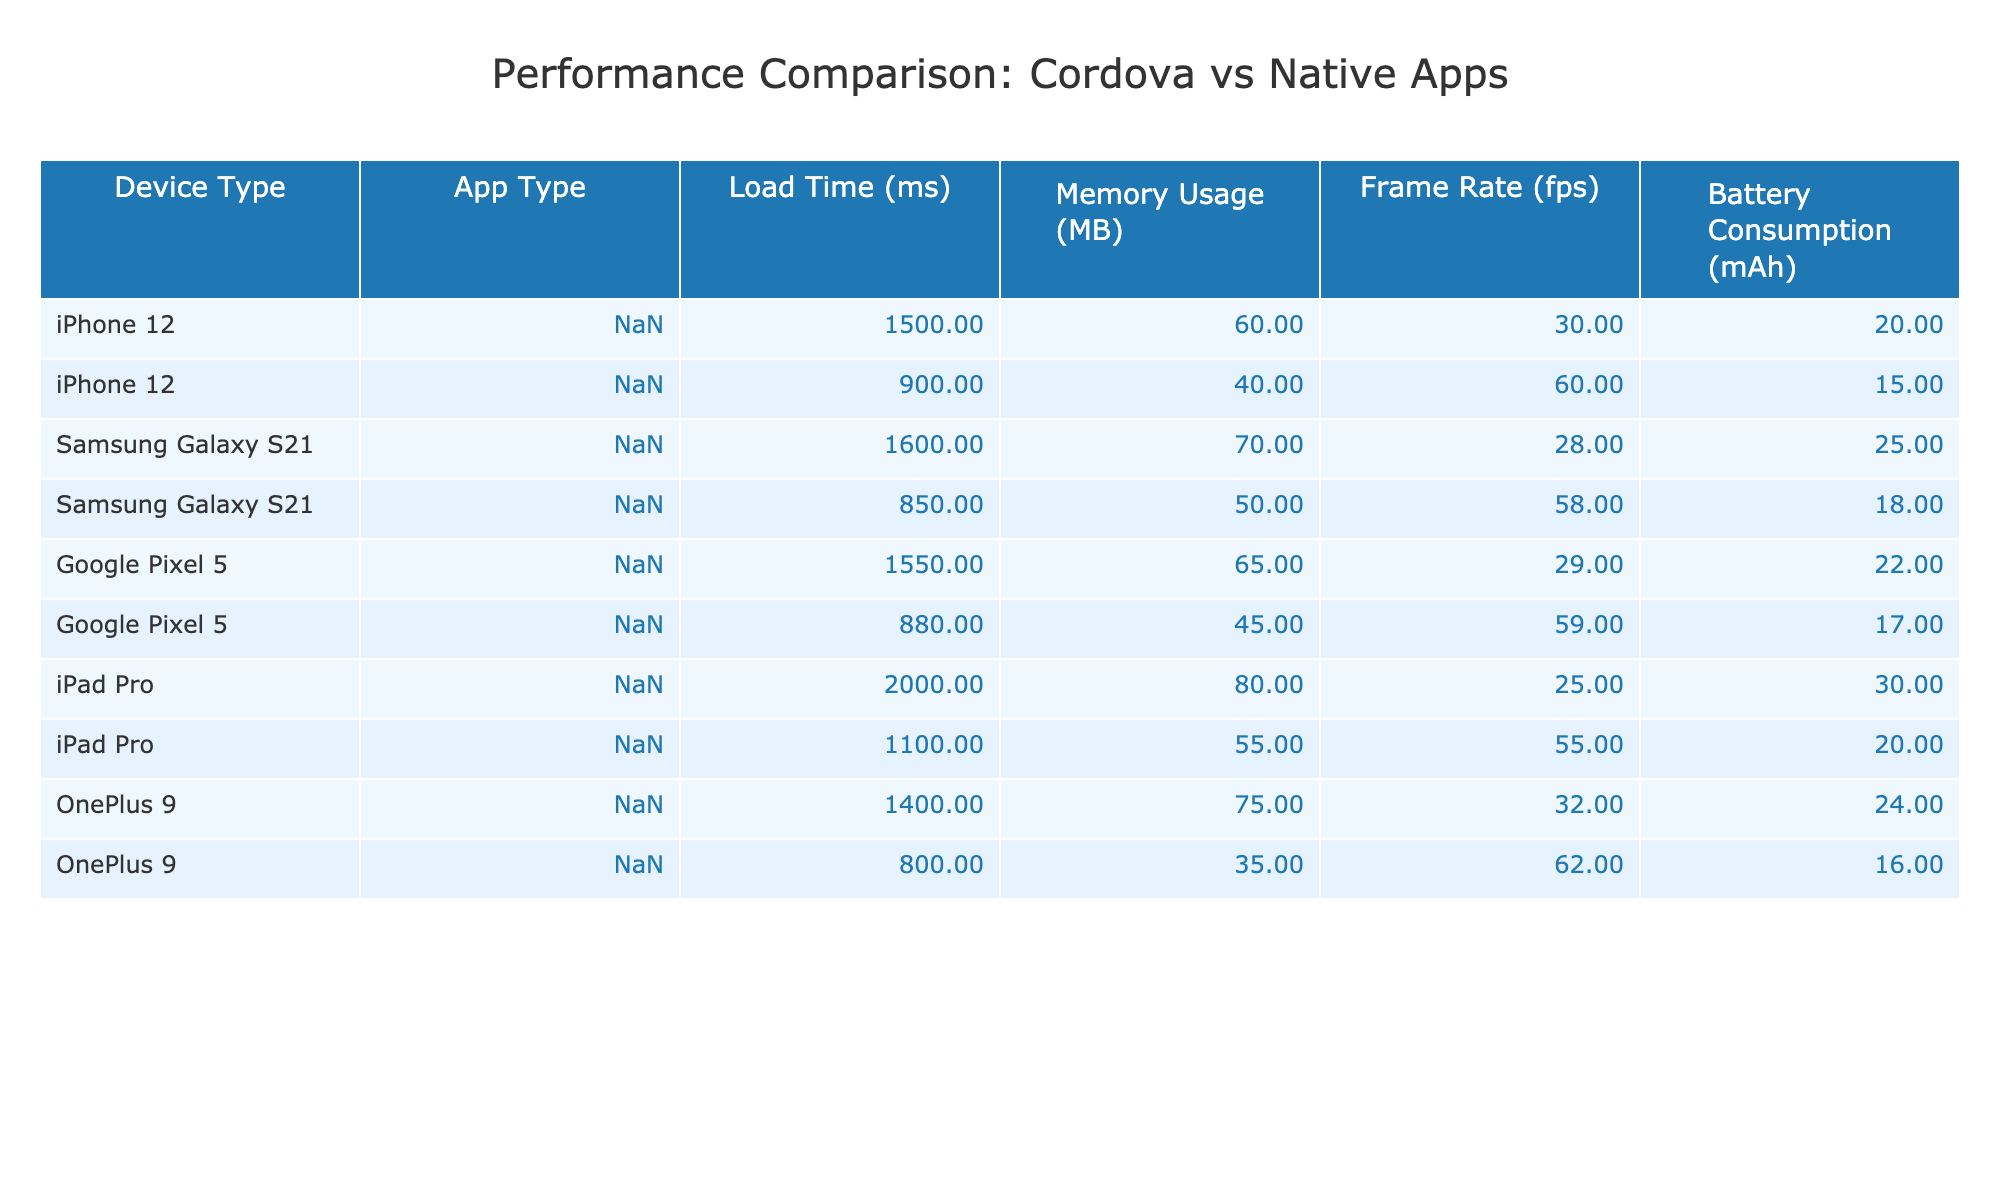What's the load time for Cordova apps on the iPhone 12? According to the table, the load time for Cordova apps on the iPhone 12 is 1500 ms.
Answer: 1500 ms Which app type consumes more memory on the Samsung Galaxy S21? The table shows that the Cordova app uses 70 MB of memory, while the Native app uses 50 MB. Therefore, the Cordova app consumes more memory.
Answer: Cordova What's the frame rate difference between the Cordova and Native apps on the Google Pixel 5? The frame rate for the Cordova app on the Google Pixel 5 is 29 fps, while for the Native app it is 59 fps. The difference is 59 - 29 = 30 fps.
Answer: 30 fps Is the battery consumption for Cordova apps generally higher than for Native apps across all device types? By looking at the table, we see that for iPhone 12, the Cordova app consumes 20 mAh, while the Native app consumes 15 mAh. For Samsung Galaxy S21, it's 25 mAh for Cordova and 18 mAh for Native. However, for Google Pixel 5, Cordova uses 22 mAh and Native uses 17 mAh, and for OnePlus 9, Cordova uses 24 mAh and Native uses 16 mAh. Therefore, the statement is true for all devices listed.
Answer: Yes What is the total load time for Native apps across all device types? The load times for Native apps are: iPhone 12 (900 ms), Samsung Galaxy S21 (850 ms), Google Pixel 5 (880 ms), iPad Pro (1100 ms), OnePlus 9 (800 ms). Summing these values gives 900 + 850 + 880 + 1100 + 800 = 4530 ms.
Answer: 4530 ms Which device has the highest load time for Cordova apps? The table indicates that the iPad Pro has the highest load time for Cordova apps at 2000 ms.
Answer: iPad Pro Based on the table, do all devices show a better frame rate for Native apps compared to Cordova apps? Looking at the frame rates, the iPhone 12 has 60 fps for Native and 30 fps for Cordova, Samsung Galaxy S21 has 58 fps for Native and 28 fps for Cordova, Google Pixel 5 has 59 fps for Native and 29 fps for Cordova, iPad Pro has 55 fps for Native and 25 fps for Cordova, and OnePlus 9 has 62 fps for Native and 32 fps for Cordova. In all cases, Native apps have a better frame rate. Therefore, the statement is true.
Answer: Yes 